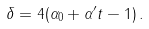<formula> <loc_0><loc_0><loc_500><loc_500>\delta = 4 ( \alpha _ { 0 } + \alpha ^ { \prime } t - 1 ) \, .</formula> 